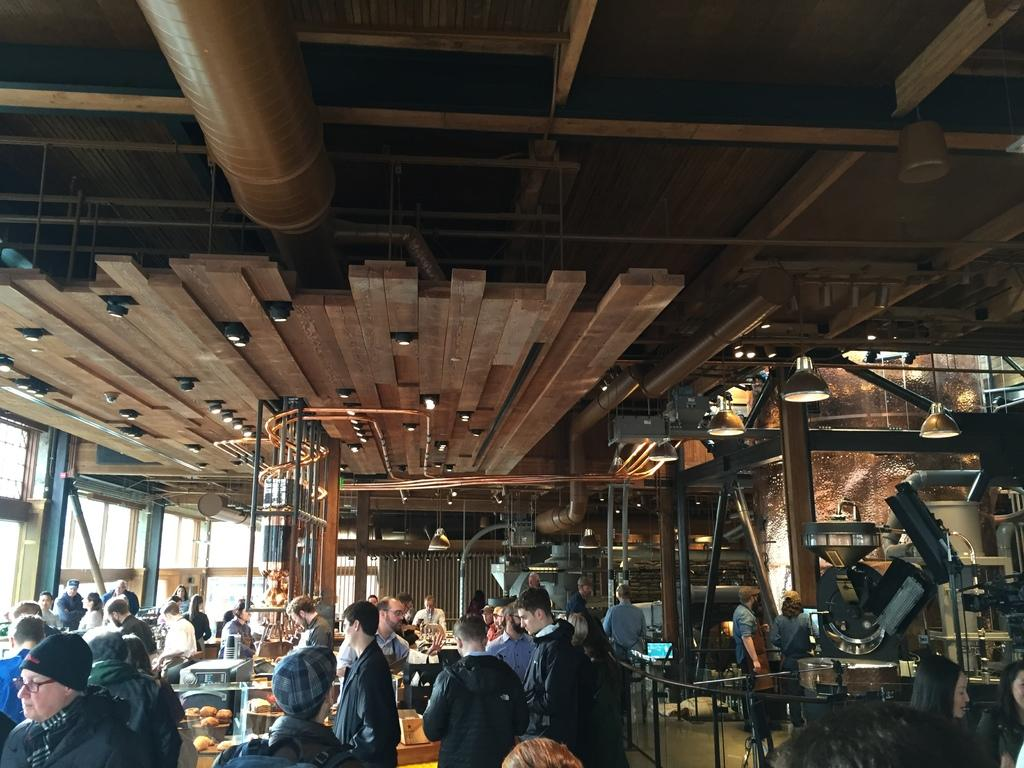What type of location is depicted in the image? The image shows an inner view of an industry. What type of lighting is used in the industry? There are electric lights in the industry. What type of equipment is present in the industry? There are grills and pipelines in the industry. What type of furniture is present in the industry? There are tables in the industry. Are there any people present in the industry? Yes, there are persons standing on the floor in the industry. What type of advice can be seen written on a quill in the image? There is no quill or advice present in the image; it shows an inner view of an industry with electric lights, grills, pipelines, tables, and people. 